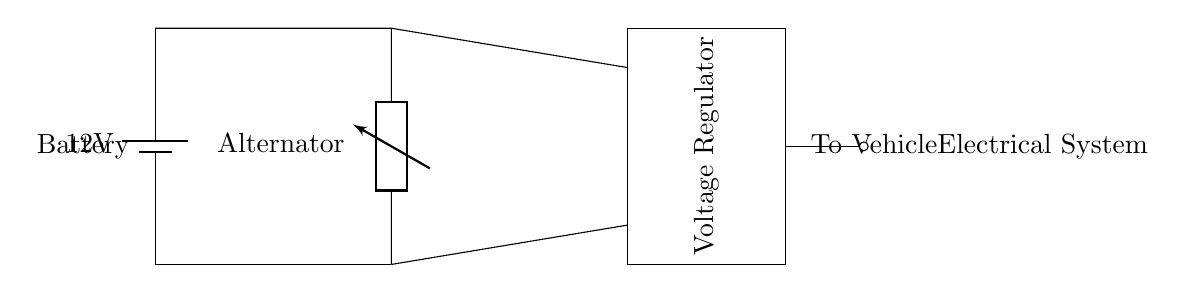What is the voltage of the battery? The circuit diagram shows a battery labeled with a voltage of 12 volts, indicating the potential difference it provides.
Answer: 12 volts What component regulates the voltage? The circuit includes a component labeled as a "Voltage Regulator," which is responsible for regulating the voltage output to the vehicle's electrical system.
Answer: Voltage Regulator How many major components are in this circuit? There are three major components depicted: a battery, an alternator, and a voltage regulator, confirming that this is a basic automotive battery charging circuit.
Answer: Three What is the function of the alternator? The alternator in the diagram is a device that generates electrical energy to charge the battery and power the vehicle's electrical systems while the engine is running.
Answer: Generates electricity Which part connects the battery to the vehicle's electrical system? The drawing shows a connection at the far right end labeled "To Vehicle Electrical System," indicating that this is the output pathway for electrical power.
Answer: Output connection What is the voltage of the alternator output? The diagram does not specify an exact voltage for the alternator; however, it is typically designed to produce a voltage higher than 12 volts to effectively charge the battery.
Answer: Not specified What type of circuit is this? This circuit can be identified as a basic automotive battery charging circuit designed to recharge the battery and supply power to the vehicle's electrical systems.
Answer: Automotive charging circuit 